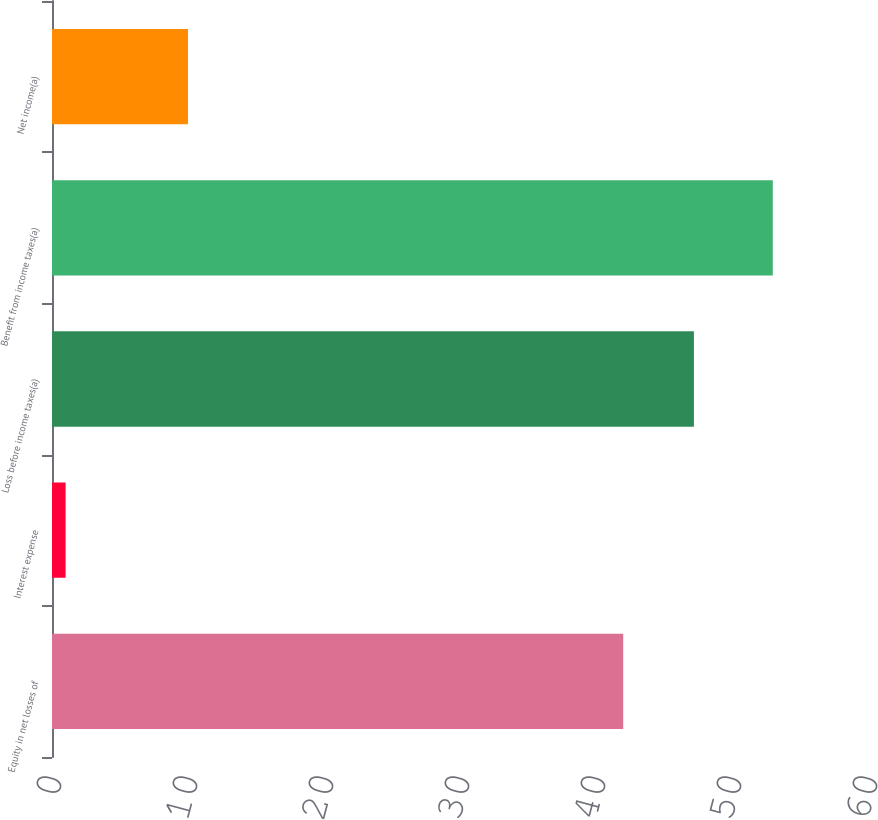Convert chart to OTSL. <chart><loc_0><loc_0><loc_500><loc_500><bar_chart><fcel>Equity in net losses of<fcel>Interest expense<fcel>Loss before income taxes(a)<fcel>Benefit from income taxes(a)<fcel>Net income(a)<nl><fcel>42<fcel>1<fcel>47.2<fcel>53<fcel>10<nl></chart> 